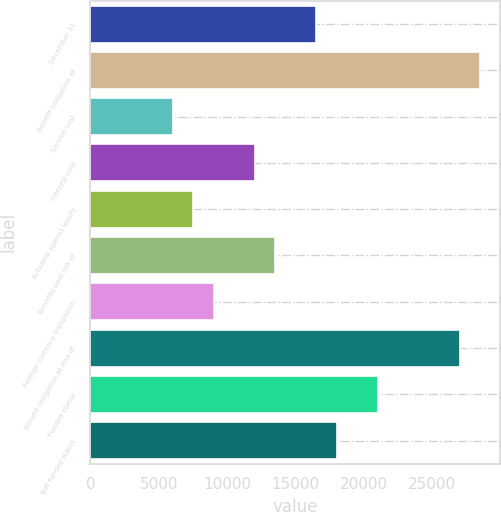Convert chart. <chart><loc_0><loc_0><loc_500><loc_500><bar_chart><fcel>December 31<fcel>Benefit obligation at<fcel>Service cost<fcel>Interest cost<fcel>Actuarial (gains) losses<fcel>Benefits paid net of<fcel>Foreign currency translation<fcel>Benefit obligation at end of<fcel>Funded status<fcel>Net funded status<nl><fcel>16520.2<fcel>28529.8<fcel>6011.8<fcel>12016.6<fcel>7513<fcel>13517.8<fcel>9014.2<fcel>27028.6<fcel>21023.8<fcel>18021.4<nl></chart> 